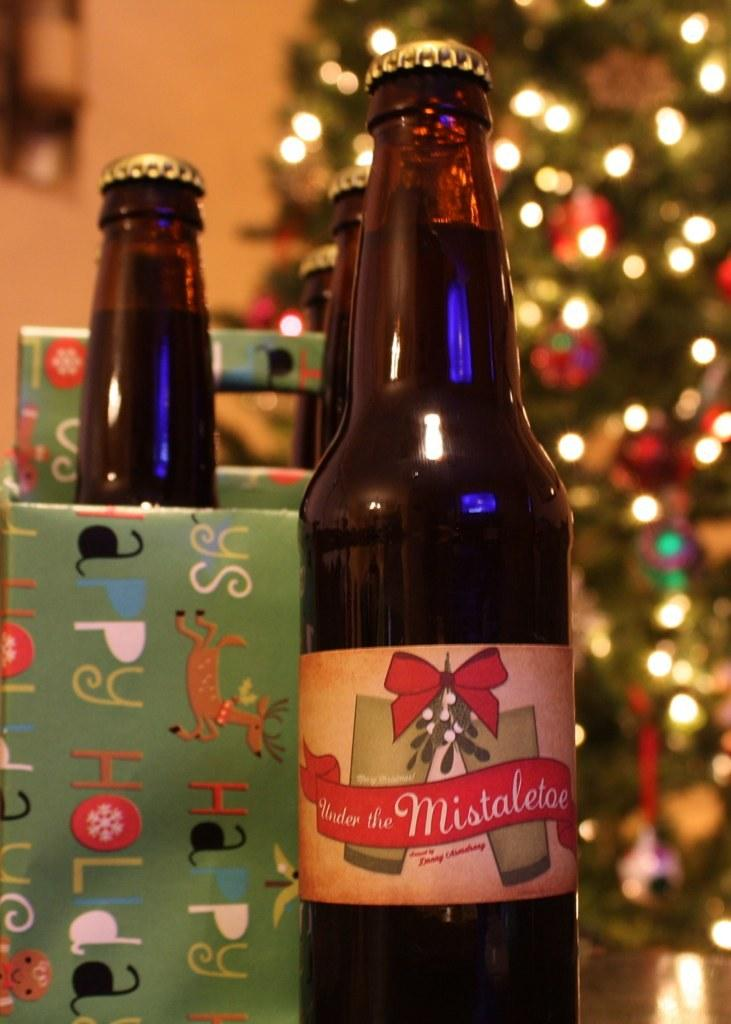<image>
Create a compact narrative representing the image presented. a bottle in front of a christmas tree that is labeled 'under the mistletoe' 